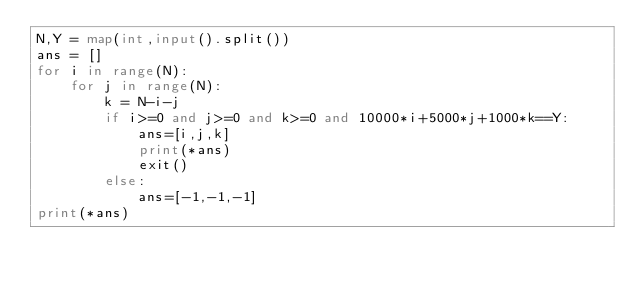<code> <loc_0><loc_0><loc_500><loc_500><_Python_>N,Y = map(int,input().split())
ans = []
for i in range(N):
    for j in range(N):
        k = N-i-j
        if i>=0 and j>=0 and k>=0 and 10000*i+5000*j+1000*k==Y:
            ans=[i,j,k]
            print(*ans)
            exit()
        else:
            ans=[-1,-1,-1]
print(*ans)</code> 